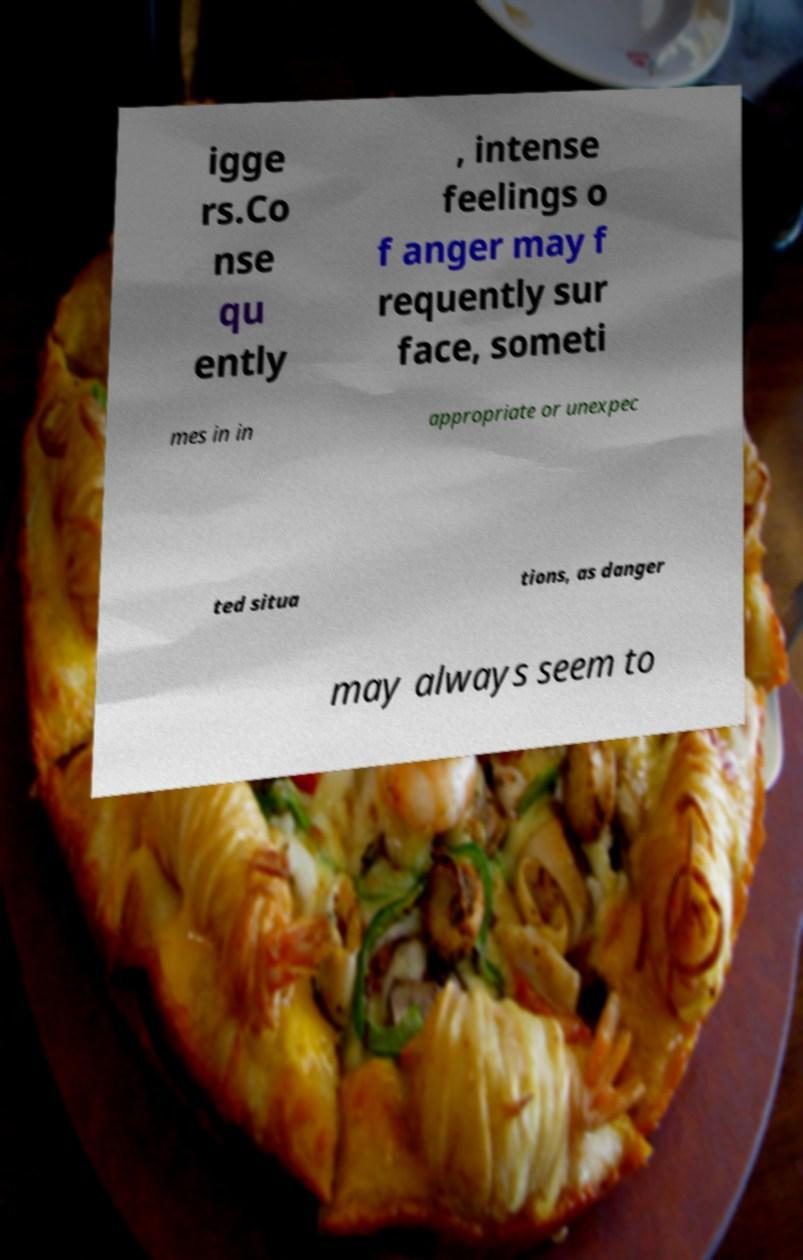Can you read and provide the text displayed in the image?This photo seems to have some interesting text. Can you extract and type it out for me? igge rs.Co nse qu ently , intense feelings o f anger may f requently sur face, someti mes in in appropriate or unexpec ted situa tions, as danger may always seem to 